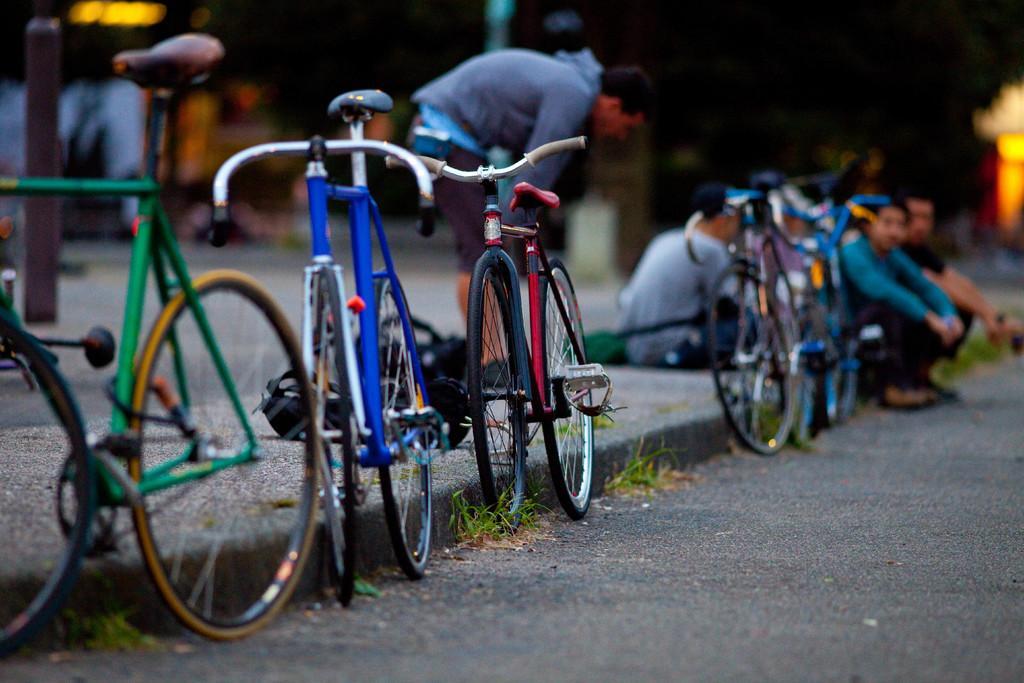Describe this image in one or two sentences. In the foreground of this image, there are bicycles and a road. In the background, there are people sitting on the side path, a man bending and a pole. The remaining objects are not clear. 